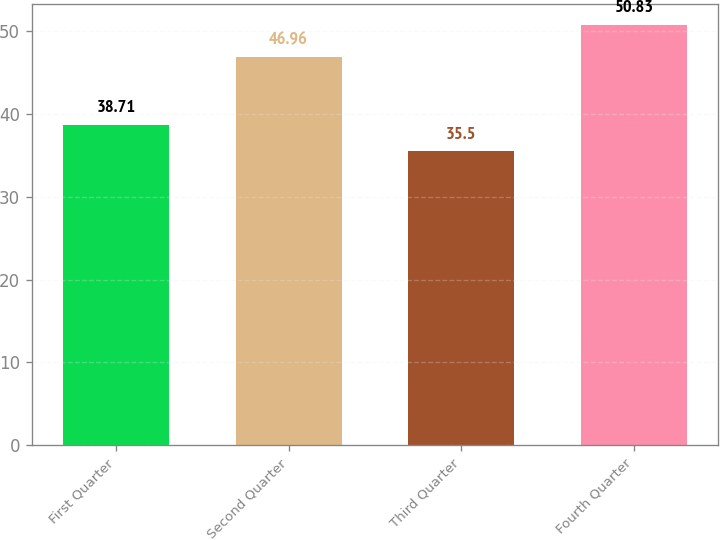Convert chart. <chart><loc_0><loc_0><loc_500><loc_500><bar_chart><fcel>First Quarter<fcel>Second Quarter<fcel>Third Quarter<fcel>Fourth Quarter<nl><fcel>38.71<fcel>46.96<fcel>35.5<fcel>50.83<nl></chart> 